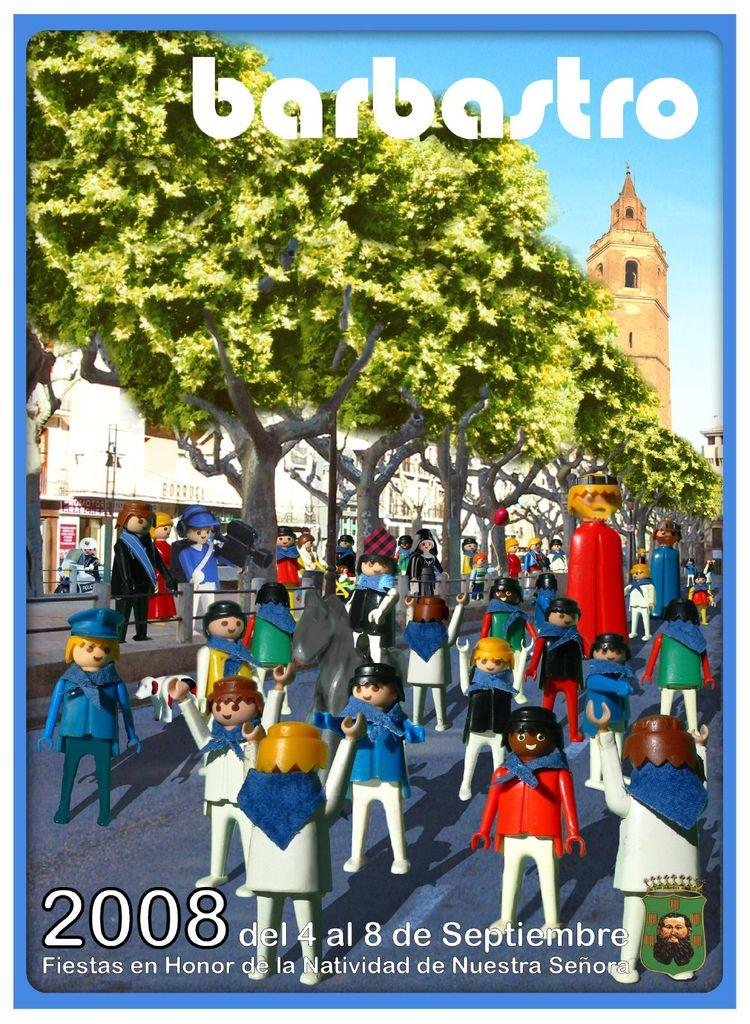<image>
Describe the image concisely. The poster is advertising an even called Barbasto which was held in 2008. 